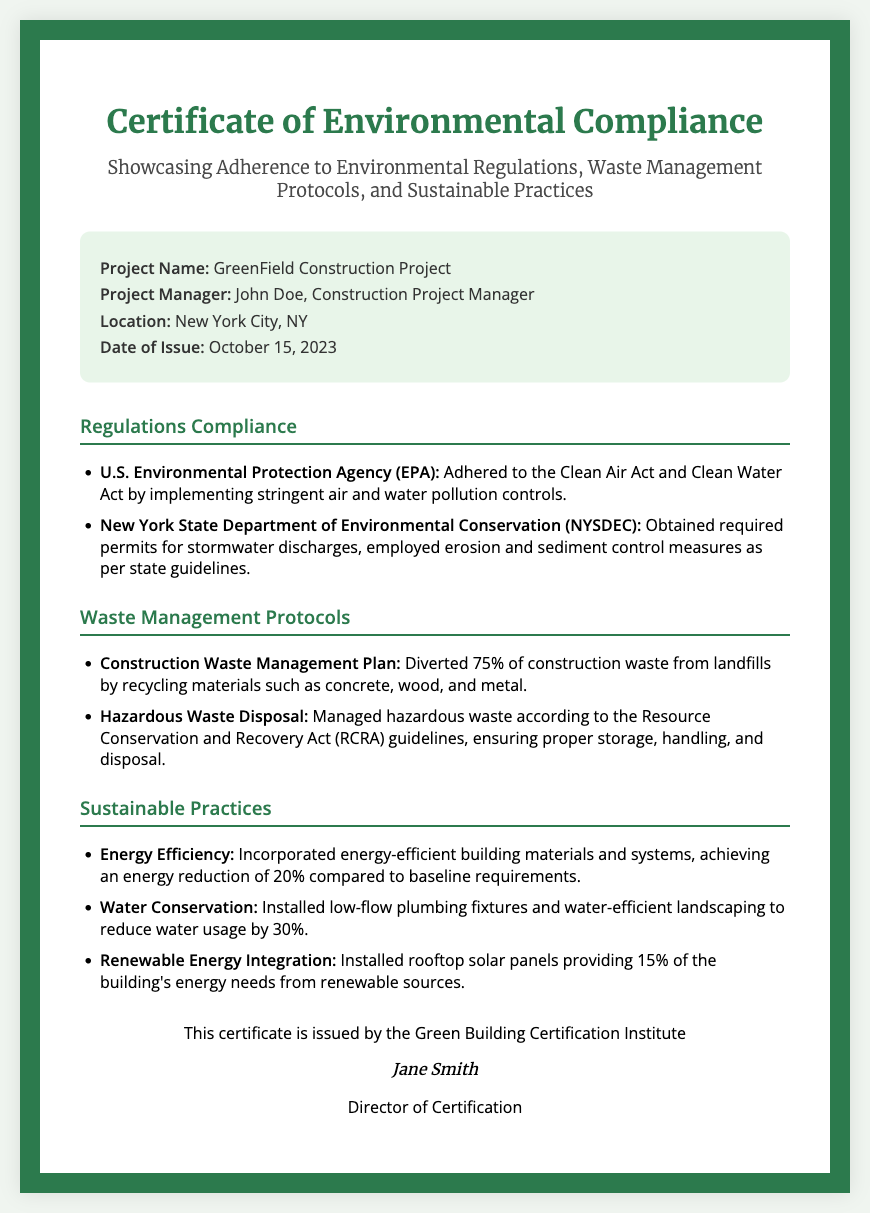what is the project name? The project name is specifically stated in the document under project details.
Answer: GreenField Construction Project who is the project manager? The project manager's name is listed in the project details section.
Answer: John Doe when was the certificate issued? The issuance date of the certificate is mentioned in the document.
Answer: October 15, 2023 how much construction waste was diverted from landfills? This information is outlined in the waste management protocols section of the document.
Answer: 75% which department issued the certificate? The issuer of the certificate is mentioned at the end of the document.
Answer: Green Building Certification Institute what percentage reduction in energy requirements was achieved? The percentage reduction in energy is detailed in the sustainable practices section.
Answer: 20% what was installed to provide renewable energy? The document describes specific installations related to renewable energy in the sustainable practices section.
Answer: Rooftop solar panels which two acts were adhered to under regulations compliance? The document lists the relevant acts in the regulations compliance section.
Answer: Clean Air Act and Clean Water Act what was the water usage reduction percentage? The reduction percentage is stated in the sustainable practices section regarding water conservation.
Answer: 30% 